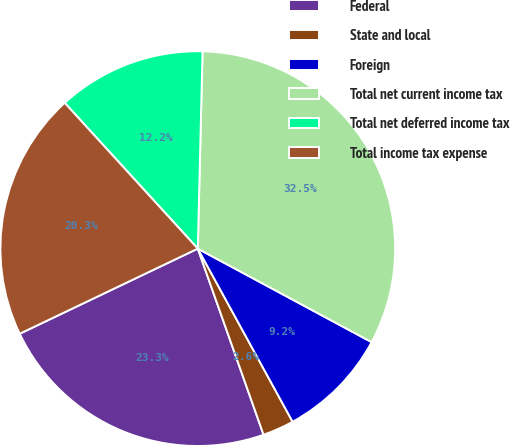<chart> <loc_0><loc_0><loc_500><loc_500><pie_chart><fcel>Federal<fcel>State and local<fcel>Foreign<fcel>Total net current income tax<fcel>Total net deferred income tax<fcel>Total income tax expense<nl><fcel>23.31%<fcel>2.57%<fcel>9.17%<fcel>32.47%<fcel>12.16%<fcel>20.32%<nl></chart> 